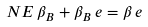Convert formula to latex. <formula><loc_0><loc_0><loc_500><loc_500>N E \, \beta _ { B } + \beta _ { B } \, e = \beta \, e</formula> 